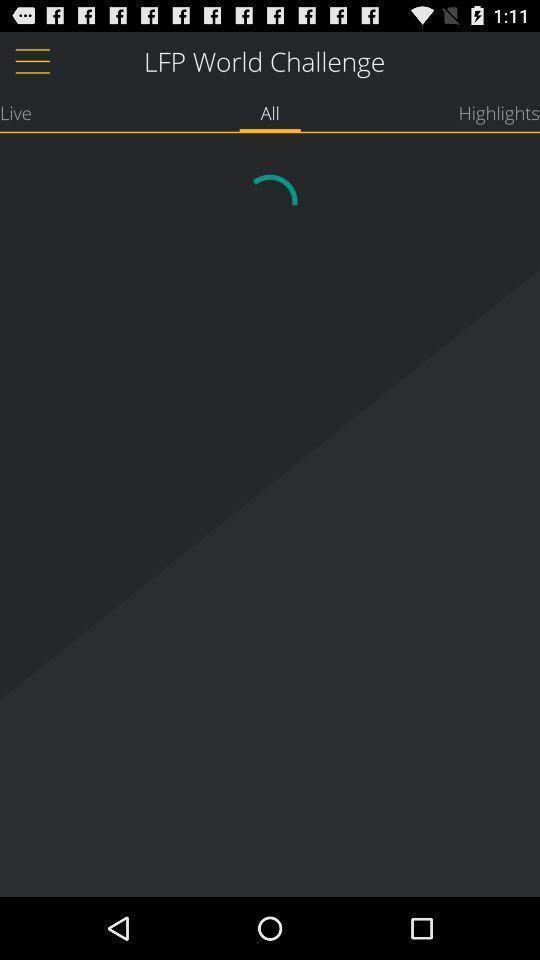Provide a description of this screenshot. Screen shows lfp world challenge loading page. 